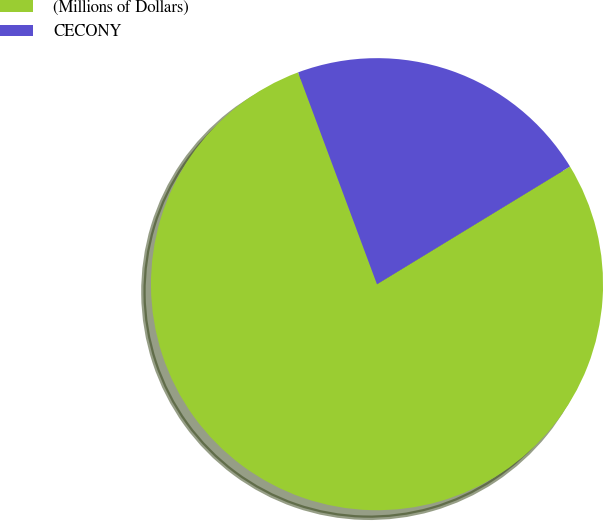Convert chart to OTSL. <chart><loc_0><loc_0><loc_500><loc_500><pie_chart><fcel>(Millions of Dollars)<fcel>CECONY<nl><fcel>78.04%<fcel>21.96%<nl></chart> 